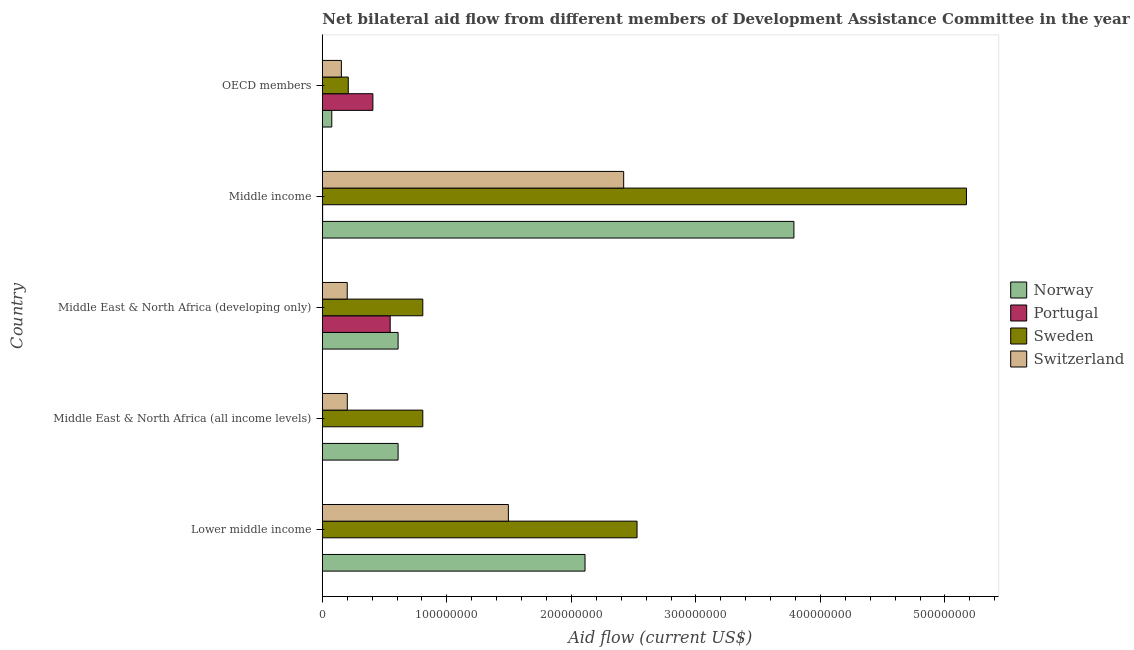How many different coloured bars are there?
Offer a terse response. 4. How many groups of bars are there?
Ensure brevity in your answer.  5. Are the number of bars per tick equal to the number of legend labels?
Give a very brief answer. Yes. Are the number of bars on each tick of the Y-axis equal?
Your answer should be compact. Yes. How many bars are there on the 2nd tick from the bottom?
Provide a short and direct response. 4. What is the label of the 1st group of bars from the top?
Your response must be concise. OECD members. In how many cases, is the number of bars for a given country not equal to the number of legend labels?
Your answer should be very brief. 0. What is the amount of aid given by norway in Lower middle income?
Keep it short and to the point. 2.11e+08. Across all countries, what is the maximum amount of aid given by sweden?
Your response must be concise. 5.17e+08. Across all countries, what is the minimum amount of aid given by norway?
Offer a terse response. 7.59e+06. In which country was the amount of aid given by sweden minimum?
Provide a short and direct response. OECD members. What is the total amount of aid given by norway in the graph?
Offer a very short reply. 7.19e+08. What is the difference between the amount of aid given by sweden in Lower middle income and that in Middle income?
Your answer should be compact. -2.65e+08. What is the difference between the amount of aid given by portugal in Middle income and the amount of aid given by sweden in Middle East & North Africa (developing only)?
Your response must be concise. -8.04e+07. What is the average amount of aid given by portugal per country?
Your answer should be compact. 1.91e+07. What is the difference between the amount of aid given by sweden and amount of aid given by portugal in Middle East & North Africa (all income levels)?
Give a very brief answer. 8.06e+07. In how many countries, is the amount of aid given by switzerland greater than 240000000 US$?
Your answer should be compact. 1. What is the ratio of the amount of aid given by switzerland in Lower middle income to that in OECD members?
Your response must be concise. 9.77. Is the difference between the amount of aid given by switzerland in Middle East & North Africa (all income levels) and OECD members greater than the difference between the amount of aid given by portugal in Middle East & North Africa (all income levels) and OECD members?
Give a very brief answer. Yes. What is the difference between the highest and the second highest amount of aid given by norway?
Offer a very short reply. 1.68e+08. What is the difference between the highest and the lowest amount of aid given by sweden?
Provide a short and direct response. 4.96e+08. In how many countries, is the amount of aid given by switzerland greater than the average amount of aid given by switzerland taken over all countries?
Your response must be concise. 2. Are all the bars in the graph horizontal?
Keep it short and to the point. Yes. How many countries are there in the graph?
Offer a very short reply. 5. What is the difference between two consecutive major ticks on the X-axis?
Your answer should be compact. 1.00e+08. Does the graph contain any zero values?
Offer a terse response. No. Does the graph contain grids?
Your answer should be very brief. No. Where does the legend appear in the graph?
Offer a terse response. Center right. How many legend labels are there?
Your response must be concise. 4. How are the legend labels stacked?
Offer a terse response. Vertical. What is the title of the graph?
Your answer should be very brief. Net bilateral aid flow from different members of Development Assistance Committee in the year 1997. What is the Aid flow (current US$) of Norway in Lower middle income?
Offer a very short reply. 2.11e+08. What is the Aid flow (current US$) in Sweden in Lower middle income?
Offer a terse response. 2.53e+08. What is the Aid flow (current US$) of Switzerland in Lower middle income?
Ensure brevity in your answer.  1.49e+08. What is the Aid flow (current US$) of Norway in Middle East & North Africa (all income levels)?
Make the answer very short. 6.08e+07. What is the Aid flow (current US$) of Sweden in Middle East & North Africa (all income levels)?
Offer a very short reply. 8.07e+07. What is the Aid flow (current US$) in Switzerland in Middle East & North Africa (all income levels)?
Provide a succinct answer. 2.00e+07. What is the Aid flow (current US$) of Norway in Middle East & North Africa (developing only)?
Your answer should be very brief. 6.08e+07. What is the Aid flow (current US$) in Portugal in Middle East & North Africa (developing only)?
Keep it short and to the point. 5.45e+07. What is the Aid flow (current US$) of Sweden in Middle East & North Africa (developing only)?
Offer a terse response. 8.07e+07. What is the Aid flow (current US$) in Switzerland in Middle East & North Africa (developing only)?
Give a very brief answer. 2.00e+07. What is the Aid flow (current US$) in Norway in Middle income?
Make the answer very short. 3.79e+08. What is the Aid flow (current US$) in Sweden in Middle income?
Your response must be concise. 5.17e+08. What is the Aid flow (current US$) in Switzerland in Middle income?
Ensure brevity in your answer.  2.42e+08. What is the Aid flow (current US$) of Norway in OECD members?
Your answer should be very brief. 7.59e+06. What is the Aid flow (current US$) of Portugal in OECD members?
Your answer should be compact. 4.06e+07. What is the Aid flow (current US$) in Sweden in OECD members?
Give a very brief answer. 2.08e+07. What is the Aid flow (current US$) of Switzerland in OECD members?
Offer a terse response. 1.53e+07. Across all countries, what is the maximum Aid flow (current US$) in Norway?
Make the answer very short. 3.79e+08. Across all countries, what is the maximum Aid flow (current US$) of Portugal?
Keep it short and to the point. 5.45e+07. Across all countries, what is the maximum Aid flow (current US$) of Sweden?
Ensure brevity in your answer.  5.17e+08. Across all countries, what is the maximum Aid flow (current US$) in Switzerland?
Your answer should be compact. 2.42e+08. Across all countries, what is the minimum Aid flow (current US$) of Norway?
Ensure brevity in your answer.  7.59e+06. Across all countries, what is the minimum Aid flow (current US$) in Sweden?
Your response must be concise. 2.08e+07. Across all countries, what is the minimum Aid flow (current US$) in Switzerland?
Offer a very short reply. 1.53e+07. What is the total Aid flow (current US$) in Norway in the graph?
Provide a succinct answer. 7.19e+08. What is the total Aid flow (current US$) of Portugal in the graph?
Provide a short and direct response. 9.56e+07. What is the total Aid flow (current US$) of Sweden in the graph?
Your response must be concise. 9.52e+08. What is the total Aid flow (current US$) of Switzerland in the graph?
Give a very brief answer. 4.47e+08. What is the difference between the Aid flow (current US$) of Norway in Lower middle income and that in Middle East & North Africa (all income levels)?
Provide a succinct answer. 1.50e+08. What is the difference between the Aid flow (current US$) of Portugal in Lower middle income and that in Middle East & North Africa (all income levels)?
Make the answer very short. 0. What is the difference between the Aid flow (current US$) of Sweden in Lower middle income and that in Middle East & North Africa (all income levels)?
Your answer should be very brief. 1.72e+08. What is the difference between the Aid flow (current US$) of Switzerland in Lower middle income and that in Middle East & North Africa (all income levels)?
Make the answer very short. 1.29e+08. What is the difference between the Aid flow (current US$) of Norway in Lower middle income and that in Middle East & North Africa (developing only)?
Your response must be concise. 1.50e+08. What is the difference between the Aid flow (current US$) in Portugal in Lower middle income and that in Middle East & North Africa (developing only)?
Provide a succinct answer. -5.44e+07. What is the difference between the Aid flow (current US$) of Sweden in Lower middle income and that in Middle East & North Africa (developing only)?
Your answer should be very brief. 1.72e+08. What is the difference between the Aid flow (current US$) of Switzerland in Lower middle income and that in Middle East & North Africa (developing only)?
Give a very brief answer. 1.29e+08. What is the difference between the Aid flow (current US$) in Norway in Lower middle income and that in Middle income?
Your answer should be compact. -1.68e+08. What is the difference between the Aid flow (current US$) of Sweden in Lower middle income and that in Middle income?
Offer a very short reply. -2.65e+08. What is the difference between the Aid flow (current US$) of Switzerland in Lower middle income and that in Middle income?
Your response must be concise. -9.26e+07. What is the difference between the Aid flow (current US$) in Norway in Lower middle income and that in OECD members?
Your answer should be compact. 2.03e+08. What is the difference between the Aid flow (current US$) in Portugal in Lower middle income and that in OECD members?
Provide a short and direct response. -4.05e+07. What is the difference between the Aid flow (current US$) in Sweden in Lower middle income and that in OECD members?
Offer a terse response. 2.32e+08. What is the difference between the Aid flow (current US$) of Switzerland in Lower middle income and that in OECD members?
Offer a terse response. 1.34e+08. What is the difference between the Aid flow (current US$) of Portugal in Middle East & North Africa (all income levels) and that in Middle East & North Africa (developing only)?
Ensure brevity in your answer.  -5.44e+07. What is the difference between the Aid flow (current US$) in Switzerland in Middle East & North Africa (all income levels) and that in Middle East & North Africa (developing only)?
Your answer should be compact. 5.00e+04. What is the difference between the Aid flow (current US$) of Norway in Middle East & North Africa (all income levels) and that in Middle income?
Your answer should be compact. -3.18e+08. What is the difference between the Aid flow (current US$) of Portugal in Middle East & North Africa (all income levels) and that in Middle income?
Your answer should be compact. -1.10e+05. What is the difference between the Aid flow (current US$) in Sweden in Middle East & North Africa (all income levels) and that in Middle income?
Provide a short and direct response. -4.37e+08. What is the difference between the Aid flow (current US$) of Switzerland in Middle East & North Africa (all income levels) and that in Middle income?
Your answer should be compact. -2.22e+08. What is the difference between the Aid flow (current US$) of Norway in Middle East & North Africa (all income levels) and that in OECD members?
Give a very brief answer. 5.32e+07. What is the difference between the Aid flow (current US$) in Portugal in Middle East & North Africa (all income levels) and that in OECD members?
Keep it short and to the point. -4.05e+07. What is the difference between the Aid flow (current US$) in Sweden in Middle East & North Africa (all income levels) and that in OECD members?
Your answer should be very brief. 5.98e+07. What is the difference between the Aid flow (current US$) of Switzerland in Middle East & North Africa (all income levels) and that in OECD members?
Your answer should be very brief. 4.76e+06. What is the difference between the Aid flow (current US$) of Norway in Middle East & North Africa (developing only) and that in Middle income?
Give a very brief answer. -3.18e+08. What is the difference between the Aid flow (current US$) in Portugal in Middle East & North Africa (developing only) and that in Middle income?
Your answer should be very brief. 5.42e+07. What is the difference between the Aid flow (current US$) in Sweden in Middle East & North Africa (developing only) and that in Middle income?
Offer a very short reply. -4.37e+08. What is the difference between the Aid flow (current US$) in Switzerland in Middle East & North Africa (developing only) and that in Middle income?
Offer a very short reply. -2.22e+08. What is the difference between the Aid flow (current US$) in Norway in Middle East & North Africa (developing only) and that in OECD members?
Provide a succinct answer. 5.32e+07. What is the difference between the Aid flow (current US$) in Portugal in Middle East & North Africa (developing only) and that in OECD members?
Keep it short and to the point. 1.39e+07. What is the difference between the Aid flow (current US$) in Sweden in Middle East & North Africa (developing only) and that in OECD members?
Offer a terse response. 5.98e+07. What is the difference between the Aid flow (current US$) of Switzerland in Middle East & North Africa (developing only) and that in OECD members?
Give a very brief answer. 4.71e+06. What is the difference between the Aid flow (current US$) of Norway in Middle income and that in OECD members?
Make the answer very short. 3.71e+08. What is the difference between the Aid flow (current US$) in Portugal in Middle income and that in OECD members?
Offer a terse response. -4.04e+07. What is the difference between the Aid flow (current US$) in Sweden in Middle income and that in OECD members?
Your response must be concise. 4.96e+08. What is the difference between the Aid flow (current US$) of Switzerland in Middle income and that in OECD members?
Keep it short and to the point. 2.27e+08. What is the difference between the Aid flow (current US$) in Norway in Lower middle income and the Aid flow (current US$) in Portugal in Middle East & North Africa (all income levels)?
Give a very brief answer. 2.11e+08. What is the difference between the Aid flow (current US$) in Norway in Lower middle income and the Aid flow (current US$) in Sweden in Middle East & North Africa (all income levels)?
Your answer should be compact. 1.30e+08. What is the difference between the Aid flow (current US$) in Norway in Lower middle income and the Aid flow (current US$) in Switzerland in Middle East & North Africa (all income levels)?
Keep it short and to the point. 1.91e+08. What is the difference between the Aid flow (current US$) of Portugal in Lower middle income and the Aid flow (current US$) of Sweden in Middle East & North Africa (all income levels)?
Your response must be concise. -8.06e+07. What is the difference between the Aid flow (current US$) in Portugal in Lower middle income and the Aid flow (current US$) in Switzerland in Middle East & North Africa (all income levels)?
Your answer should be very brief. -1.99e+07. What is the difference between the Aid flow (current US$) of Sweden in Lower middle income and the Aid flow (current US$) of Switzerland in Middle East & North Africa (all income levels)?
Provide a short and direct response. 2.33e+08. What is the difference between the Aid flow (current US$) in Norway in Lower middle income and the Aid flow (current US$) in Portugal in Middle East & North Africa (developing only)?
Ensure brevity in your answer.  1.56e+08. What is the difference between the Aid flow (current US$) of Norway in Lower middle income and the Aid flow (current US$) of Sweden in Middle East & North Africa (developing only)?
Provide a succinct answer. 1.30e+08. What is the difference between the Aid flow (current US$) in Norway in Lower middle income and the Aid flow (current US$) in Switzerland in Middle East & North Africa (developing only)?
Keep it short and to the point. 1.91e+08. What is the difference between the Aid flow (current US$) in Portugal in Lower middle income and the Aid flow (current US$) in Sweden in Middle East & North Africa (developing only)?
Your response must be concise. -8.06e+07. What is the difference between the Aid flow (current US$) in Portugal in Lower middle income and the Aid flow (current US$) in Switzerland in Middle East & North Africa (developing only)?
Offer a very short reply. -1.99e+07. What is the difference between the Aid flow (current US$) in Sweden in Lower middle income and the Aid flow (current US$) in Switzerland in Middle East & North Africa (developing only)?
Offer a terse response. 2.33e+08. What is the difference between the Aid flow (current US$) in Norway in Lower middle income and the Aid flow (current US$) in Portugal in Middle income?
Make the answer very short. 2.11e+08. What is the difference between the Aid flow (current US$) in Norway in Lower middle income and the Aid flow (current US$) in Sweden in Middle income?
Offer a terse response. -3.06e+08. What is the difference between the Aid flow (current US$) in Norway in Lower middle income and the Aid flow (current US$) in Switzerland in Middle income?
Offer a very short reply. -3.10e+07. What is the difference between the Aid flow (current US$) of Portugal in Lower middle income and the Aid flow (current US$) of Sweden in Middle income?
Ensure brevity in your answer.  -5.17e+08. What is the difference between the Aid flow (current US$) of Portugal in Lower middle income and the Aid flow (current US$) of Switzerland in Middle income?
Offer a very short reply. -2.42e+08. What is the difference between the Aid flow (current US$) in Sweden in Lower middle income and the Aid flow (current US$) in Switzerland in Middle income?
Your answer should be compact. 1.07e+07. What is the difference between the Aid flow (current US$) in Norway in Lower middle income and the Aid flow (current US$) in Portugal in OECD members?
Offer a very short reply. 1.70e+08. What is the difference between the Aid flow (current US$) in Norway in Lower middle income and the Aid flow (current US$) in Sweden in OECD members?
Provide a short and direct response. 1.90e+08. What is the difference between the Aid flow (current US$) in Norway in Lower middle income and the Aid flow (current US$) in Switzerland in OECD members?
Provide a short and direct response. 1.96e+08. What is the difference between the Aid flow (current US$) in Portugal in Lower middle income and the Aid flow (current US$) in Sweden in OECD members?
Your answer should be compact. -2.07e+07. What is the difference between the Aid flow (current US$) in Portugal in Lower middle income and the Aid flow (current US$) in Switzerland in OECD members?
Provide a short and direct response. -1.52e+07. What is the difference between the Aid flow (current US$) of Sweden in Lower middle income and the Aid flow (current US$) of Switzerland in OECD members?
Offer a very short reply. 2.37e+08. What is the difference between the Aid flow (current US$) in Norway in Middle East & North Africa (all income levels) and the Aid flow (current US$) in Portugal in Middle East & North Africa (developing only)?
Provide a succinct answer. 6.35e+06. What is the difference between the Aid flow (current US$) of Norway in Middle East & North Africa (all income levels) and the Aid flow (current US$) of Sweden in Middle East & North Africa (developing only)?
Ensure brevity in your answer.  -1.98e+07. What is the difference between the Aid flow (current US$) of Norway in Middle East & North Africa (all income levels) and the Aid flow (current US$) of Switzerland in Middle East & North Africa (developing only)?
Your answer should be compact. 4.08e+07. What is the difference between the Aid flow (current US$) in Portugal in Middle East & North Africa (all income levels) and the Aid flow (current US$) in Sweden in Middle East & North Africa (developing only)?
Keep it short and to the point. -8.06e+07. What is the difference between the Aid flow (current US$) in Portugal in Middle East & North Africa (all income levels) and the Aid flow (current US$) in Switzerland in Middle East & North Africa (developing only)?
Offer a very short reply. -1.99e+07. What is the difference between the Aid flow (current US$) of Sweden in Middle East & North Africa (all income levels) and the Aid flow (current US$) of Switzerland in Middle East & North Africa (developing only)?
Provide a succinct answer. 6.07e+07. What is the difference between the Aid flow (current US$) in Norway in Middle East & North Africa (all income levels) and the Aid flow (current US$) in Portugal in Middle income?
Your answer should be very brief. 6.06e+07. What is the difference between the Aid flow (current US$) in Norway in Middle East & North Africa (all income levels) and the Aid flow (current US$) in Sweden in Middle income?
Offer a terse response. -4.56e+08. What is the difference between the Aid flow (current US$) of Norway in Middle East & North Africa (all income levels) and the Aid flow (current US$) of Switzerland in Middle income?
Ensure brevity in your answer.  -1.81e+08. What is the difference between the Aid flow (current US$) of Portugal in Middle East & North Africa (all income levels) and the Aid flow (current US$) of Sweden in Middle income?
Your response must be concise. -5.17e+08. What is the difference between the Aid flow (current US$) of Portugal in Middle East & North Africa (all income levels) and the Aid flow (current US$) of Switzerland in Middle income?
Offer a terse response. -2.42e+08. What is the difference between the Aid flow (current US$) in Sweden in Middle East & North Africa (all income levels) and the Aid flow (current US$) in Switzerland in Middle income?
Your response must be concise. -1.61e+08. What is the difference between the Aid flow (current US$) in Norway in Middle East & North Africa (all income levels) and the Aid flow (current US$) in Portugal in OECD members?
Provide a short and direct response. 2.02e+07. What is the difference between the Aid flow (current US$) in Norway in Middle East & North Africa (all income levels) and the Aid flow (current US$) in Sweden in OECD members?
Your answer should be very brief. 4.00e+07. What is the difference between the Aid flow (current US$) of Norway in Middle East & North Africa (all income levels) and the Aid flow (current US$) of Switzerland in OECD members?
Your answer should be compact. 4.56e+07. What is the difference between the Aid flow (current US$) in Portugal in Middle East & North Africa (all income levels) and the Aid flow (current US$) in Sweden in OECD members?
Make the answer very short. -2.07e+07. What is the difference between the Aid flow (current US$) in Portugal in Middle East & North Africa (all income levels) and the Aid flow (current US$) in Switzerland in OECD members?
Offer a very short reply. -1.52e+07. What is the difference between the Aid flow (current US$) of Sweden in Middle East & North Africa (all income levels) and the Aid flow (current US$) of Switzerland in OECD members?
Offer a very short reply. 6.54e+07. What is the difference between the Aid flow (current US$) in Norway in Middle East & North Africa (developing only) and the Aid flow (current US$) in Portugal in Middle income?
Offer a terse response. 6.06e+07. What is the difference between the Aid flow (current US$) in Norway in Middle East & North Africa (developing only) and the Aid flow (current US$) in Sweden in Middle income?
Your response must be concise. -4.56e+08. What is the difference between the Aid flow (current US$) of Norway in Middle East & North Africa (developing only) and the Aid flow (current US$) of Switzerland in Middle income?
Your answer should be very brief. -1.81e+08. What is the difference between the Aid flow (current US$) of Portugal in Middle East & North Africa (developing only) and the Aid flow (current US$) of Sweden in Middle income?
Offer a terse response. -4.63e+08. What is the difference between the Aid flow (current US$) of Portugal in Middle East & North Africa (developing only) and the Aid flow (current US$) of Switzerland in Middle income?
Give a very brief answer. -1.88e+08. What is the difference between the Aid flow (current US$) of Sweden in Middle East & North Africa (developing only) and the Aid flow (current US$) of Switzerland in Middle income?
Offer a terse response. -1.61e+08. What is the difference between the Aid flow (current US$) in Norway in Middle East & North Africa (developing only) and the Aid flow (current US$) in Portugal in OECD members?
Provide a succinct answer. 2.02e+07. What is the difference between the Aid flow (current US$) of Norway in Middle East & North Africa (developing only) and the Aid flow (current US$) of Sweden in OECD members?
Your answer should be compact. 4.00e+07. What is the difference between the Aid flow (current US$) in Norway in Middle East & North Africa (developing only) and the Aid flow (current US$) in Switzerland in OECD members?
Give a very brief answer. 4.56e+07. What is the difference between the Aid flow (current US$) of Portugal in Middle East & North Africa (developing only) and the Aid flow (current US$) of Sweden in OECD members?
Make the answer very short. 3.36e+07. What is the difference between the Aid flow (current US$) of Portugal in Middle East & North Africa (developing only) and the Aid flow (current US$) of Switzerland in OECD members?
Offer a very short reply. 3.92e+07. What is the difference between the Aid flow (current US$) of Sweden in Middle East & North Africa (developing only) and the Aid flow (current US$) of Switzerland in OECD members?
Offer a very short reply. 6.54e+07. What is the difference between the Aid flow (current US$) of Norway in Middle income and the Aid flow (current US$) of Portugal in OECD members?
Keep it short and to the point. 3.38e+08. What is the difference between the Aid flow (current US$) in Norway in Middle income and the Aid flow (current US$) in Sweden in OECD members?
Keep it short and to the point. 3.58e+08. What is the difference between the Aid flow (current US$) in Norway in Middle income and the Aid flow (current US$) in Switzerland in OECD members?
Provide a succinct answer. 3.63e+08. What is the difference between the Aid flow (current US$) in Portugal in Middle income and the Aid flow (current US$) in Sweden in OECD members?
Offer a very short reply. -2.06e+07. What is the difference between the Aid flow (current US$) of Portugal in Middle income and the Aid flow (current US$) of Switzerland in OECD members?
Make the answer very short. -1.50e+07. What is the difference between the Aid flow (current US$) in Sweden in Middle income and the Aid flow (current US$) in Switzerland in OECD members?
Give a very brief answer. 5.02e+08. What is the average Aid flow (current US$) of Norway per country?
Provide a short and direct response. 1.44e+08. What is the average Aid flow (current US$) of Portugal per country?
Offer a very short reply. 1.91e+07. What is the average Aid flow (current US$) of Sweden per country?
Ensure brevity in your answer.  1.90e+08. What is the average Aid flow (current US$) of Switzerland per country?
Provide a short and direct response. 8.93e+07. What is the difference between the Aid flow (current US$) in Norway and Aid flow (current US$) in Portugal in Lower middle income?
Provide a succinct answer. 2.11e+08. What is the difference between the Aid flow (current US$) in Norway and Aid flow (current US$) in Sweden in Lower middle income?
Your answer should be very brief. -4.18e+07. What is the difference between the Aid flow (current US$) of Norway and Aid flow (current US$) of Switzerland in Lower middle income?
Give a very brief answer. 6.16e+07. What is the difference between the Aid flow (current US$) of Portugal and Aid flow (current US$) of Sweden in Lower middle income?
Make the answer very short. -2.53e+08. What is the difference between the Aid flow (current US$) of Portugal and Aid flow (current US$) of Switzerland in Lower middle income?
Provide a short and direct response. -1.49e+08. What is the difference between the Aid flow (current US$) of Sweden and Aid flow (current US$) of Switzerland in Lower middle income?
Ensure brevity in your answer.  1.03e+08. What is the difference between the Aid flow (current US$) in Norway and Aid flow (current US$) in Portugal in Middle East & North Africa (all income levels)?
Your answer should be very brief. 6.07e+07. What is the difference between the Aid flow (current US$) of Norway and Aid flow (current US$) of Sweden in Middle East & North Africa (all income levels)?
Your answer should be compact. -1.98e+07. What is the difference between the Aid flow (current US$) in Norway and Aid flow (current US$) in Switzerland in Middle East & North Africa (all income levels)?
Keep it short and to the point. 4.08e+07. What is the difference between the Aid flow (current US$) of Portugal and Aid flow (current US$) of Sweden in Middle East & North Africa (all income levels)?
Offer a very short reply. -8.06e+07. What is the difference between the Aid flow (current US$) in Portugal and Aid flow (current US$) in Switzerland in Middle East & North Africa (all income levels)?
Give a very brief answer. -1.99e+07. What is the difference between the Aid flow (current US$) of Sweden and Aid flow (current US$) of Switzerland in Middle East & North Africa (all income levels)?
Provide a succinct answer. 6.06e+07. What is the difference between the Aid flow (current US$) of Norway and Aid flow (current US$) of Portugal in Middle East & North Africa (developing only)?
Provide a short and direct response. 6.35e+06. What is the difference between the Aid flow (current US$) of Norway and Aid flow (current US$) of Sweden in Middle East & North Africa (developing only)?
Ensure brevity in your answer.  -1.98e+07. What is the difference between the Aid flow (current US$) of Norway and Aid flow (current US$) of Switzerland in Middle East & North Africa (developing only)?
Your answer should be very brief. 4.08e+07. What is the difference between the Aid flow (current US$) in Portugal and Aid flow (current US$) in Sweden in Middle East & North Africa (developing only)?
Provide a short and direct response. -2.62e+07. What is the difference between the Aid flow (current US$) of Portugal and Aid flow (current US$) of Switzerland in Middle East & North Africa (developing only)?
Give a very brief answer. 3.45e+07. What is the difference between the Aid flow (current US$) of Sweden and Aid flow (current US$) of Switzerland in Middle East & North Africa (developing only)?
Your answer should be very brief. 6.07e+07. What is the difference between the Aid flow (current US$) in Norway and Aid flow (current US$) in Portugal in Middle income?
Offer a terse response. 3.78e+08. What is the difference between the Aid flow (current US$) in Norway and Aid flow (current US$) in Sweden in Middle income?
Make the answer very short. -1.39e+08. What is the difference between the Aid flow (current US$) in Norway and Aid flow (current US$) in Switzerland in Middle income?
Provide a succinct answer. 1.37e+08. What is the difference between the Aid flow (current US$) in Portugal and Aid flow (current US$) in Sweden in Middle income?
Give a very brief answer. -5.17e+08. What is the difference between the Aid flow (current US$) in Portugal and Aid flow (current US$) in Switzerland in Middle income?
Give a very brief answer. -2.42e+08. What is the difference between the Aid flow (current US$) in Sweden and Aid flow (current US$) in Switzerland in Middle income?
Provide a succinct answer. 2.75e+08. What is the difference between the Aid flow (current US$) of Norway and Aid flow (current US$) of Portugal in OECD members?
Offer a terse response. -3.30e+07. What is the difference between the Aid flow (current US$) in Norway and Aid flow (current US$) in Sweden in OECD members?
Provide a succinct answer. -1.32e+07. What is the difference between the Aid flow (current US$) in Norway and Aid flow (current US$) in Switzerland in OECD members?
Keep it short and to the point. -7.70e+06. What is the difference between the Aid flow (current US$) of Portugal and Aid flow (current US$) of Sweden in OECD members?
Keep it short and to the point. 1.98e+07. What is the difference between the Aid flow (current US$) in Portugal and Aid flow (current US$) in Switzerland in OECD members?
Give a very brief answer. 2.53e+07. What is the difference between the Aid flow (current US$) of Sweden and Aid flow (current US$) of Switzerland in OECD members?
Provide a short and direct response. 5.55e+06. What is the ratio of the Aid flow (current US$) in Norway in Lower middle income to that in Middle East & North Africa (all income levels)?
Offer a terse response. 3.47. What is the ratio of the Aid flow (current US$) of Portugal in Lower middle income to that in Middle East & North Africa (all income levels)?
Your answer should be compact. 1. What is the ratio of the Aid flow (current US$) in Sweden in Lower middle income to that in Middle East & North Africa (all income levels)?
Provide a succinct answer. 3.13. What is the ratio of the Aid flow (current US$) in Switzerland in Lower middle income to that in Middle East & North Africa (all income levels)?
Make the answer very short. 7.45. What is the ratio of the Aid flow (current US$) of Norway in Lower middle income to that in Middle East & North Africa (developing only)?
Your response must be concise. 3.47. What is the ratio of the Aid flow (current US$) in Portugal in Lower middle income to that in Middle East & North Africa (developing only)?
Keep it short and to the point. 0. What is the ratio of the Aid flow (current US$) of Sweden in Lower middle income to that in Middle East & North Africa (developing only)?
Give a very brief answer. 3.13. What is the ratio of the Aid flow (current US$) in Switzerland in Lower middle income to that in Middle East & North Africa (developing only)?
Your answer should be very brief. 7.47. What is the ratio of the Aid flow (current US$) of Norway in Lower middle income to that in Middle income?
Give a very brief answer. 0.56. What is the ratio of the Aid flow (current US$) of Portugal in Lower middle income to that in Middle income?
Offer a terse response. 0.54. What is the ratio of the Aid flow (current US$) of Sweden in Lower middle income to that in Middle income?
Your answer should be very brief. 0.49. What is the ratio of the Aid flow (current US$) in Switzerland in Lower middle income to that in Middle income?
Offer a very short reply. 0.62. What is the ratio of the Aid flow (current US$) of Norway in Lower middle income to that in OECD members?
Provide a succinct answer. 27.79. What is the ratio of the Aid flow (current US$) in Portugal in Lower middle income to that in OECD members?
Offer a very short reply. 0. What is the ratio of the Aid flow (current US$) in Sweden in Lower middle income to that in OECD members?
Make the answer very short. 12.13. What is the ratio of the Aid flow (current US$) of Switzerland in Lower middle income to that in OECD members?
Provide a short and direct response. 9.77. What is the ratio of the Aid flow (current US$) in Norway in Middle East & North Africa (all income levels) to that in Middle East & North Africa (developing only)?
Provide a succinct answer. 1. What is the ratio of the Aid flow (current US$) in Portugal in Middle East & North Africa (all income levels) to that in Middle East & North Africa (developing only)?
Provide a succinct answer. 0. What is the ratio of the Aid flow (current US$) of Norway in Middle East & North Africa (all income levels) to that in Middle income?
Keep it short and to the point. 0.16. What is the ratio of the Aid flow (current US$) of Portugal in Middle East & North Africa (all income levels) to that in Middle income?
Provide a succinct answer. 0.54. What is the ratio of the Aid flow (current US$) in Sweden in Middle East & North Africa (all income levels) to that in Middle income?
Provide a short and direct response. 0.16. What is the ratio of the Aid flow (current US$) in Switzerland in Middle East & North Africa (all income levels) to that in Middle income?
Provide a short and direct response. 0.08. What is the ratio of the Aid flow (current US$) of Norway in Middle East & North Africa (all income levels) to that in OECD members?
Your response must be concise. 8.02. What is the ratio of the Aid flow (current US$) of Portugal in Middle East & North Africa (all income levels) to that in OECD members?
Your answer should be very brief. 0. What is the ratio of the Aid flow (current US$) in Sweden in Middle East & North Africa (all income levels) to that in OECD members?
Keep it short and to the point. 3.87. What is the ratio of the Aid flow (current US$) in Switzerland in Middle East & North Africa (all income levels) to that in OECD members?
Your answer should be very brief. 1.31. What is the ratio of the Aid flow (current US$) in Norway in Middle East & North Africa (developing only) to that in Middle income?
Keep it short and to the point. 0.16. What is the ratio of the Aid flow (current US$) in Portugal in Middle East & North Africa (developing only) to that in Middle income?
Give a very brief answer. 227.04. What is the ratio of the Aid flow (current US$) in Sweden in Middle East & North Africa (developing only) to that in Middle income?
Your response must be concise. 0.16. What is the ratio of the Aid flow (current US$) in Switzerland in Middle East & North Africa (developing only) to that in Middle income?
Give a very brief answer. 0.08. What is the ratio of the Aid flow (current US$) in Norway in Middle East & North Africa (developing only) to that in OECD members?
Provide a short and direct response. 8.02. What is the ratio of the Aid flow (current US$) in Portugal in Middle East & North Africa (developing only) to that in OECD members?
Provide a short and direct response. 1.34. What is the ratio of the Aid flow (current US$) in Sweden in Middle East & North Africa (developing only) to that in OECD members?
Your answer should be very brief. 3.87. What is the ratio of the Aid flow (current US$) of Switzerland in Middle East & North Africa (developing only) to that in OECD members?
Your answer should be compact. 1.31. What is the ratio of the Aid flow (current US$) in Norway in Middle income to that in OECD members?
Offer a very short reply. 49.89. What is the ratio of the Aid flow (current US$) of Portugal in Middle income to that in OECD members?
Your answer should be very brief. 0.01. What is the ratio of the Aid flow (current US$) of Sweden in Middle income to that in OECD members?
Your answer should be very brief. 24.82. What is the ratio of the Aid flow (current US$) of Switzerland in Middle income to that in OECD members?
Your answer should be very brief. 15.83. What is the difference between the highest and the second highest Aid flow (current US$) in Norway?
Offer a terse response. 1.68e+08. What is the difference between the highest and the second highest Aid flow (current US$) in Portugal?
Offer a terse response. 1.39e+07. What is the difference between the highest and the second highest Aid flow (current US$) of Sweden?
Your response must be concise. 2.65e+08. What is the difference between the highest and the second highest Aid flow (current US$) of Switzerland?
Give a very brief answer. 9.26e+07. What is the difference between the highest and the lowest Aid flow (current US$) in Norway?
Your answer should be compact. 3.71e+08. What is the difference between the highest and the lowest Aid flow (current US$) in Portugal?
Make the answer very short. 5.44e+07. What is the difference between the highest and the lowest Aid flow (current US$) in Sweden?
Give a very brief answer. 4.96e+08. What is the difference between the highest and the lowest Aid flow (current US$) in Switzerland?
Make the answer very short. 2.27e+08. 